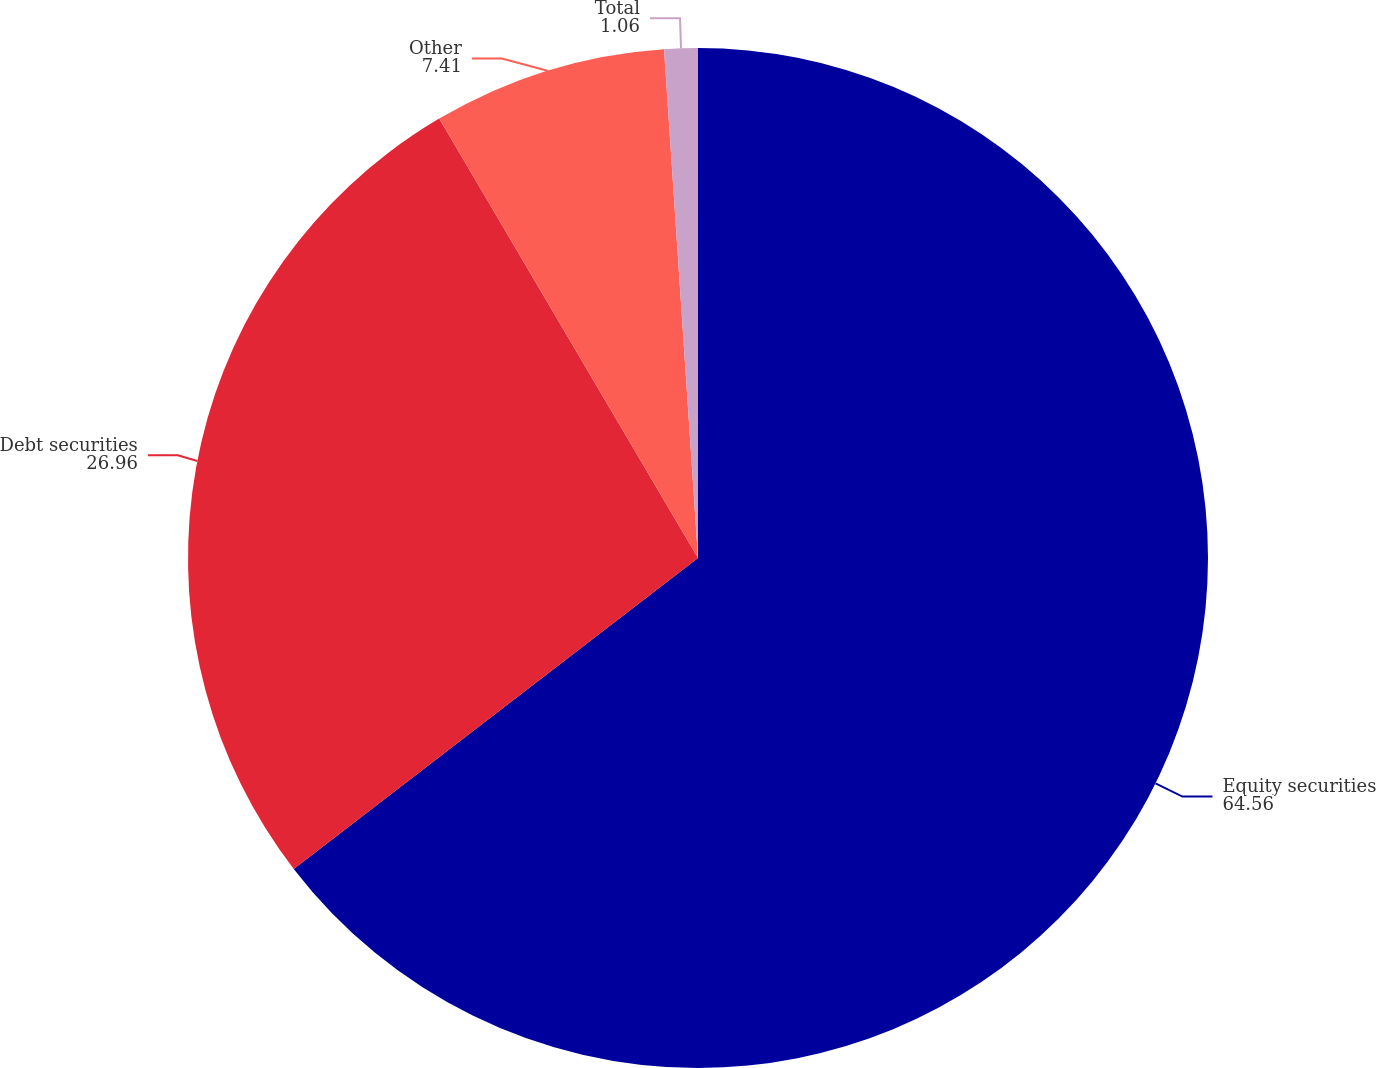Convert chart to OTSL. <chart><loc_0><loc_0><loc_500><loc_500><pie_chart><fcel>Equity securities<fcel>Debt securities<fcel>Other<fcel>Total<nl><fcel>64.56%<fcel>26.96%<fcel>7.41%<fcel>1.06%<nl></chart> 